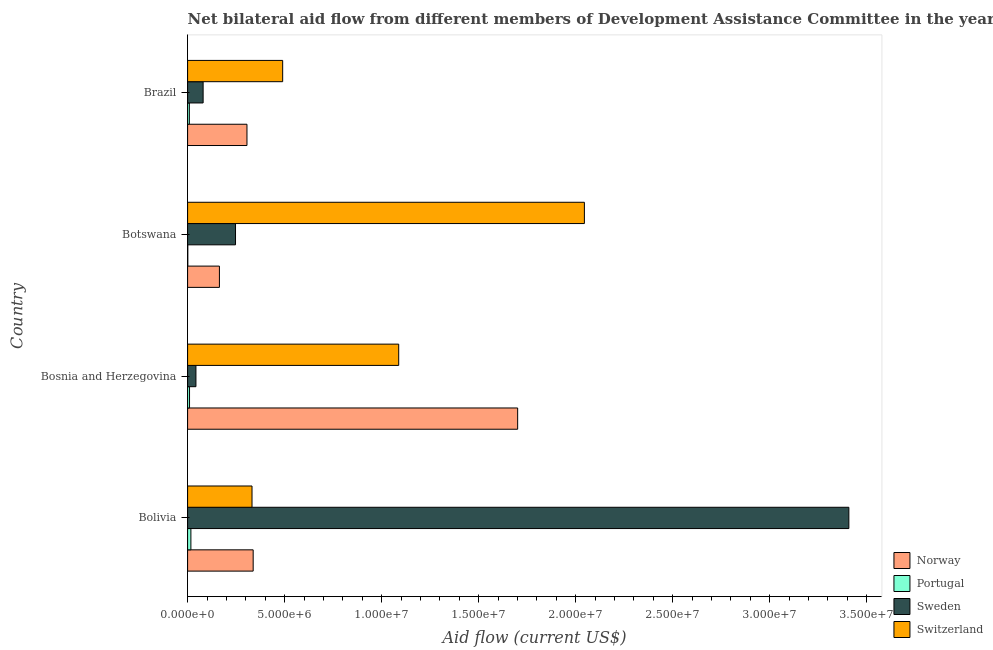How many different coloured bars are there?
Provide a short and direct response. 4. How many groups of bars are there?
Give a very brief answer. 4. Are the number of bars per tick equal to the number of legend labels?
Your answer should be compact. Yes. Are the number of bars on each tick of the Y-axis equal?
Make the answer very short. Yes. How many bars are there on the 1st tick from the bottom?
Provide a succinct answer. 4. What is the label of the 2nd group of bars from the top?
Offer a very short reply. Botswana. In how many cases, is the number of bars for a given country not equal to the number of legend labels?
Your answer should be very brief. 0. What is the amount of aid given by sweden in Bolivia?
Offer a terse response. 3.41e+07. Across all countries, what is the maximum amount of aid given by switzerland?
Provide a succinct answer. 2.04e+07. Across all countries, what is the minimum amount of aid given by portugal?
Ensure brevity in your answer.  10000. In which country was the amount of aid given by norway minimum?
Your answer should be very brief. Botswana. What is the total amount of aid given by switzerland in the graph?
Ensure brevity in your answer.  3.96e+07. What is the difference between the amount of aid given by switzerland in Botswana and that in Brazil?
Give a very brief answer. 1.56e+07. What is the difference between the amount of aid given by switzerland in Brazil and the amount of aid given by portugal in Bolivia?
Provide a short and direct response. 4.73e+06. What is the average amount of aid given by sweden per country?
Offer a terse response. 9.44e+06. What is the difference between the amount of aid given by switzerland and amount of aid given by sweden in Bolivia?
Provide a succinct answer. -3.08e+07. What is the ratio of the amount of aid given by switzerland in Bolivia to that in Botswana?
Keep it short and to the point. 0.16. What is the difference between the highest and the second highest amount of aid given by sweden?
Offer a very short reply. 3.16e+07. What is the difference between the highest and the lowest amount of aid given by sweden?
Make the answer very short. 3.36e+07. In how many countries, is the amount of aid given by switzerland greater than the average amount of aid given by switzerland taken over all countries?
Give a very brief answer. 2. Is the sum of the amount of aid given by portugal in Bolivia and Bosnia and Herzegovina greater than the maximum amount of aid given by norway across all countries?
Your response must be concise. No. What does the 1st bar from the bottom in Bosnia and Herzegovina represents?
Your response must be concise. Norway. Are all the bars in the graph horizontal?
Your response must be concise. Yes. Are the values on the major ticks of X-axis written in scientific E-notation?
Your response must be concise. Yes. Does the graph contain grids?
Give a very brief answer. No. Where does the legend appear in the graph?
Give a very brief answer. Bottom right. How many legend labels are there?
Provide a succinct answer. 4. How are the legend labels stacked?
Offer a very short reply. Vertical. What is the title of the graph?
Offer a terse response. Net bilateral aid flow from different members of Development Assistance Committee in the year 2004. What is the label or title of the X-axis?
Give a very brief answer. Aid flow (current US$). What is the Aid flow (current US$) in Norway in Bolivia?
Your answer should be very brief. 3.38e+06. What is the Aid flow (current US$) in Sweden in Bolivia?
Provide a short and direct response. 3.41e+07. What is the Aid flow (current US$) in Switzerland in Bolivia?
Offer a very short reply. 3.32e+06. What is the Aid flow (current US$) in Norway in Bosnia and Herzegovina?
Provide a succinct answer. 1.70e+07. What is the Aid flow (current US$) in Portugal in Bosnia and Herzegovina?
Provide a short and direct response. 1.00e+05. What is the Aid flow (current US$) in Switzerland in Bosnia and Herzegovina?
Your response must be concise. 1.09e+07. What is the Aid flow (current US$) of Norway in Botswana?
Give a very brief answer. 1.64e+06. What is the Aid flow (current US$) of Sweden in Botswana?
Your answer should be very brief. 2.47e+06. What is the Aid flow (current US$) in Switzerland in Botswana?
Give a very brief answer. 2.04e+07. What is the Aid flow (current US$) of Norway in Brazil?
Provide a short and direct response. 3.06e+06. What is the Aid flow (current US$) of Sweden in Brazil?
Provide a succinct answer. 8.00e+05. What is the Aid flow (current US$) of Switzerland in Brazil?
Give a very brief answer. 4.90e+06. Across all countries, what is the maximum Aid flow (current US$) in Norway?
Give a very brief answer. 1.70e+07. Across all countries, what is the maximum Aid flow (current US$) in Portugal?
Make the answer very short. 1.70e+05. Across all countries, what is the maximum Aid flow (current US$) in Sweden?
Your answer should be very brief. 3.41e+07. Across all countries, what is the maximum Aid flow (current US$) in Switzerland?
Provide a succinct answer. 2.04e+07. Across all countries, what is the minimum Aid flow (current US$) in Norway?
Provide a short and direct response. 1.64e+06. Across all countries, what is the minimum Aid flow (current US$) in Portugal?
Your answer should be very brief. 10000. Across all countries, what is the minimum Aid flow (current US$) in Switzerland?
Ensure brevity in your answer.  3.32e+06. What is the total Aid flow (current US$) of Norway in the graph?
Your answer should be very brief. 2.51e+07. What is the total Aid flow (current US$) of Portugal in the graph?
Your answer should be very brief. 3.70e+05. What is the total Aid flow (current US$) of Sweden in the graph?
Offer a very short reply. 3.78e+07. What is the total Aid flow (current US$) in Switzerland in the graph?
Your response must be concise. 3.96e+07. What is the difference between the Aid flow (current US$) of Norway in Bolivia and that in Bosnia and Herzegovina?
Your response must be concise. -1.36e+07. What is the difference between the Aid flow (current US$) of Sweden in Bolivia and that in Bosnia and Herzegovina?
Offer a very short reply. 3.36e+07. What is the difference between the Aid flow (current US$) of Switzerland in Bolivia and that in Bosnia and Herzegovina?
Give a very brief answer. -7.56e+06. What is the difference between the Aid flow (current US$) in Norway in Bolivia and that in Botswana?
Give a very brief answer. 1.74e+06. What is the difference between the Aid flow (current US$) of Sweden in Bolivia and that in Botswana?
Your answer should be very brief. 3.16e+07. What is the difference between the Aid flow (current US$) of Switzerland in Bolivia and that in Botswana?
Provide a short and direct response. -1.71e+07. What is the difference between the Aid flow (current US$) in Norway in Bolivia and that in Brazil?
Provide a short and direct response. 3.20e+05. What is the difference between the Aid flow (current US$) in Portugal in Bolivia and that in Brazil?
Ensure brevity in your answer.  8.00e+04. What is the difference between the Aid flow (current US$) of Sweden in Bolivia and that in Brazil?
Give a very brief answer. 3.33e+07. What is the difference between the Aid flow (current US$) of Switzerland in Bolivia and that in Brazil?
Keep it short and to the point. -1.58e+06. What is the difference between the Aid flow (current US$) of Norway in Bosnia and Herzegovina and that in Botswana?
Offer a terse response. 1.54e+07. What is the difference between the Aid flow (current US$) of Portugal in Bosnia and Herzegovina and that in Botswana?
Provide a succinct answer. 9.00e+04. What is the difference between the Aid flow (current US$) in Sweden in Bosnia and Herzegovina and that in Botswana?
Make the answer very short. -2.04e+06. What is the difference between the Aid flow (current US$) of Switzerland in Bosnia and Herzegovina and that in Botswana?
Your answer should be very brief. -9.57e+06. What is the difference between the Aid flow (current US$) of Norway in Bosnia and Herzegovina and that in Brazil?
Provide a succinct answer. 1.40e+07. What is the difference between the Aid flow (current US$) of Portugal in Bosnia and Herzegovina and that in Brazil?
Keep it short and to the point. 10000. What is the difference between the Aid flow (current US$) of Sweden in Bosnia and Herzegovina and that in Brazil?
Make the answer very short. -3.70e+05. What is the difference between the Aid flow (current US$) in Switzerland in Bosnia and Herzegovina and that in Brazil?
Provide a short and direct response. 5.98e+06. What is the difference between the Aid flow (current US$) in Norway in Botswana and that in Brazil?
Offer a terse response. -1.42e+06. What is the difference between the Aid flow (current US$) of Sweden in Botswana and that in Brazil?
Your answer should be compact. 1.67e+06. What is the difference between the Aid flow (current US$) in Switzerland in Botswana and that in Brazil?
Provide a succinct answer. 1.56e+07. What is the difference between the Aid flow (current US$) of Norway in Bolivia and the Aid flow (current US$) of Portugal in Bosnia and Herzegovina?
Ensure brevity in your answer.  3.28e+06. What is the difference between the Aid flow (current US$) of Norway in Bolivia and the Aid flow (current US$) of Sweden in Bosnia and Herzegovina?
Make the answer very short. 2.95e+06. What is the difference between the Aid flow (current US$) of Norway in Bolivia and the Aid flow (current US$) of Switzerland in Bosnia and Herzegovina?
Provide a succinct answer. -7.50e+06. What is the difference between the Aid flow (current US$) in Portugal in Bolivia and the Aid flow (current US$) in Switzerland in Bosnia and Herzegovina?
Your answer should be very brief. -1.07e+07. What is the difference between the Aid flow (current US$) in Sweden in Bolivia and the Aid flow (current US$) in Switzerland in Bosnia and Herzegovina?
Keep it short and to the point. 2.32e+07. What is the difference between the Aid flow (current US$) in Norway in Bolivia and the Aid flow (current US$) in Portugal in Botswana?
Make the answer very short. 3.37e+06. What is the difference between the Aid flow (current US$) in Norway in Bolivia and the Aid flow (current US$) in Sweden in Botswana?
Make the answer very short. 9.10e+05. What is the difference between the Aid flow (current US$) of Norway in Bolivia and the Aid flow (current US$) of Switzerland in Botswana?
Make the answer very short. -1.71e+07. What is the difference between the Aid flow (current US$) in Portugal in Bolivia and the Aid flow (current US$) in Sweden in Botswana?
Give a very brief answer. -2.30e+06. What is the difference between the Aid flow (current US$) of Portugal in Bolivia and the Aid flow (current US$) of Switzerland in Botswana?
Make the answer very short. -2.03e+07. What is the difference between the Aid flow (current US$) in Sweden in Bolivia and the Aid flow (current US$) in Switzerland in Botswana?
Ensure brevity in your answer.  1.36e+07. What is the difference between the Aid flow (current US$) of Norway in Bolivia and the Aid flow (current US$) of Portugal in Brazil?
Make the answer very short. 3.29e+06. What is the difference between the Aid flow (current US$) in Norway in Bolivia and the Aid flow (current US$) in Sweden in Brazil?
Provide a short and direct response. 2.58e+06. What is the difference between the Aid flow (current US$) in Norway in Bolivia and the Aid flow (current US$) in Switzerland in Brazil?
Your answer should be very brief. -1.52e+06. What is the difference between the Aid flow (current US$) of Portugal in Bolivia and the Aid flow (current US$) of Sweden in Brazil?
Your answer should be compact. -6.30e+05. What is the difference between the Aid flow (current US$) of Portugal in Bolivia and the Aid flow (current US$) of Switzerland in Brazil?
Provide a succinct answer. -4.73e+06. What is the difference between the Aid flow (current US$) in Sweden in Bolivia and the Aid flow (current US$) in Switzerland in Brazil?
Provide a succinct answer. 2.92e+07. What is the difference between the Aid flow (current US$) of Norway in Bosnia and Herzegovina and the Aid flow (current US$) of Portugal in Botswana?
Your response must be concise. 1.70e+07. What is the difference between the Aid flow (current US$) of Norway in Bosnia and Herzegovina and the Aid flow (current US$) of Sweden in Botswana?
Offer a very short reply. 1.45e+07. What is the difference between the Aid flow (current US$) of Norway in Bosnia and Herzegovina and the Aid flow (current US$) of Switzerland in Botswana?
Your answer should be very brief. -3.44e+06. What is the difference between the Aid flow (current US$) in Portugal in Bosnia and Herzegovina and the Aid flow (current US$) in Sweden in Botswana?
Give a very brief answer. -2.37e+06. What is the difference between the Aid flow (current US$) in Portugal in Bosnia and Herzegovina and the Aid flow (current US$) in Switzerland in Botswana?
Ensure brevity in your answer.  -2.04e+07. What is the difference between the Aid flow (current US$) of Sweden in Bosnia and Herzegovina and the Aid flow (current US$) of Switzerland in Botswana?
Offer a terse response. -2.00e+07. What is the difference between the Aid flow (current US$) in Norway in Bosnia and Herzegovina and the Aid flow (current US$) in Portugal in Brazil?
Provide a short and direct response. 1.69e+07. What is the difference between the Aid flow (current US$) of Norway in Bosnia and Herzegovina and the Aid flow (current US$) of Sweden in Brazil?
Ensure brevity in your answer.  1.62e+07. What is the difference between the Aid flow (current US$) in Norway in Bosnia and Herzegovina and the Aid flow (current US$) in Switzerland in Brazil?
Your response must be concise. 1.21e+07. What is the difference between the Aid flow (current US$) in Portugal in Bosnia and Herzegovina and the Aid flow (current US$) in Sweden in Brazil?
Make the answer very short. -7.00e+05. What is the difference between the Aid flow (current US$) of Portugal in Bosnia and Herzegovina and the Aid flow (current US$) of Switzerland in Brazil?
Keep it short and to the point. -4.80e+06. What is the difference between the Aid flow (current US$) in Sweden in Bosnia and Herzegovina and the Aid flow (current US$) in Switzerland in Brazil?
Offer a very short reply. -4.47e+06. What is the difference between the Aid flow (current US$) of Norway in Botswana and the Aid flow (current US$) of Portugal in Brazil?
Keep it short and to the point. 1.55e+06. What is the difference between the Aid flow (current US$) of Norway in Botswana and the Aid flow (current US$) of Sweden in Brazil?
Your answer should be very brief. 8.40e+05. What is the difference between the Aid flow (current US$) of Norway in Botswana and the Aid flow (current US$) of Switzerland in Brazil?
Provide a short and direct response. -3.26e+06. What is the difference between the Aid flow (current US$) in Portugal in Botswana and the Aid flow (current US$) in Sweden in Brazil?
Provide a succinct answer. -7.90e+05. What is the difference between the Aid flow (current US$) of Portugal in Botswana and the Aid flow (current US$) of Switzerland in Brazil?
Provide a short and direct response. -4.89e+06. What is the difference between the Aid flow (current US$) in Sweden in Botswana and the Aid flow (current US$) in Switzerland in Brazil?
Your answer should be very brief. -2.43e+06. What is the average Aid flow (current US$) in Norway per country?
Make the answer very short. 6.27e+06. What is the average Aid flow (current US$) of Portugal per country?
Your answer should be very brief. 9.25e+04. What is the average Aid flow (current US$) of Sweden per country?
Your answer should be very brief. 9.44e+06. What is the average Aid flow (current US$) in Switzerland per country?
Make the answer very short. 9.89e+06. What is the difference between the Aid flow (current US$) of Norway and Aid flow (current US$) of Portugal in Bolivia?
Give a very brief answer. 3.21e+06. What is the difference between the Aid flow (current US$) of Norway and Aid flow (current US$) of Sweden in Bolivia?
Your response must be concise. -3.07e+07. What is the difference between the Aid flow (current US$) in Norway and Aid flow (current US$) in Switzerland in Bolivia?
Provide a short and direct response. 6.00e+04. What is the difference between the Aid flow (current US$) of Portugal and Aid flow (current US$) of Sweden in Bolivia?
Your answer should be very brief. -3.39e+07. What is the difference between the Aid flow (current US$) of Portugal and Aid flow (current US$) of Switzerland in Bolivia?
Ensure brevity in your answer.  -3.15e+06. What is the difference between the Aid flow (current US$) in Sweden and Aid flow (current US$) in Switzerland in Bolivia?
Your answer should be compact. 3.08e+07. What is the difference between the Aid flow (current US$) of Norway and Aid flow (current US$) of Portugal in Bosnia and Herzegovina?
Ensure brevity in your answer.  1.69e+07. What is the difference between the Aid flow (current US$) of Norway and Aid flow (current US$) of Sweden in Bosnia and Herzegovina?
Your response must be concise. 1.66e+07. What is the difference between the Aid flow (current US$) of Norway and Aid flow (current US$) of Switzerland in Bosnia and Herzegovina?
Ensure brevity in your answer.  6.13e+06. What is the difference between the Aid flow (current US$) of Portugal and Aid flow (current US$) of Sweden in Bosnia and Herzegovina?
Keep it short and to the point. -3.30e+05. What is the difference between the Aid flow (current US$) in Portugal and Aid flow (current US$) in Switzerland in Bosnia and Herzegovina?
Offer a terse response. -1.08e+07. What is the difference between the Aid flow (current US$) in Sweden and Aid flow (current US$) in Switzerland in Bosnia and Herzegovina?
Your answer should be compact. -1.04e+07. What is the difference between the Aid flow (current US$) of Norway and Aid flow (current US$) of Portugal in Botswana?
Offer a very short reply. 1.63e+06. What is the difference between the Aid flow (current US$) in Norway and Aid flow (current US$) in Sweden in Botswana?
Make the answer very short. -8.30e+05. What is the difference between the Aid flow (current US$) in Norway and Aid flow (current US$) in Switzerland in Botswana?
Your response must be concise. -1.88e+07. What is the difference between the Aid flow (current US$) in Portugal and Aid flow (current US$) in Sweden in Botswana?
Ensure brevity in your answer.  -2.46e+06. What is the difference between the Aid flow (current US$) of Portugal and Aid flow (current US$) of Switzerland in Botswana?
Provide a short and direct response. -2.04e+07. What is the difference between the Aid flow (current US$) of Sweden and Aid flow (current US$) of Switzerland in Botswana?
Provide a short and direct response. -1.80e+07. What is the difference between the Aid flow (current US$) in Norway and Aid flow (current US$) in Portugal in Brazil?
Ensure brevity in your answer.  2.97e+06. What is the difference between the Aid flow (current US$) in Norway and Aid flow (current US$) in Sweden in Brazil?
Provide a short and direct response. 2.26e+06. What is the difference between the Aid flow (current US$) of Norway and Aid flow (current US$) of Switzerland in Brazil?
Offer a very short reply. -1.84e+06. What is the difference between the Aid flow (current US$) of Portugal and Aid flow (current US$) of Sweden in Brazil?
Your answer should be very brief. -7.10e+05. What is the difference between the Aid flow (current US$) in Portugal and Aid flow (current US$) in Switzerland in Brazil?
Your response must be concise. -4.81e+06. What is the difference between the Aid flow (current US$) in Sweden and Aid flow (current US$) in Switzerland in Brazil?
Provide a short and direct response. -4.10e+06. What is the ratio of the Aid flow (current US$) of Norway in Bolivia to that in Bosnia and Herzegovina?
Give a very brief answer. 0.2. What is the ratio of the Aid flow (current US$) of Portugal in Bolivia to that in Bosnia and Herzegovina?
Make the answer very short. 1.7. What is the ratio of the Aid flow (current US$) of Sweden in Bolivia to that in Bosnia and Herzegovina?
Your response must be concise. 79.26. What is the ratio of the Aid flow (current US$) of Switzerland in Bolivia to that in Bosnia and Herzegovina?
Offer a very short reply. 0.31. What is the ratio of the Aid flow (current US$) in Norway in Bolivia to that in Botswana?
Offer a very short reply. 2.06. What is the ratio of the Aid flow (current US$) of Portugal in Bolivia to that in Botswana?
Your answer should be very brief. 17. What is the ratio of the Aid flow (current US$) in Sweden in Bolivia to that in Botswana?
Provide a short and direct response. 13.8. What is the ratio of the Aid flow (current US$) in Switzerland in Bolivia to that in Botswana?
Provide a short and direct response. 0.16. What is the ratio of the Aid flow (current US$) in Norway in Bolivia to that in Brazil?
Offer a terse response. 1.1. What is the ratio of the Aid flow (current US$) of Portugal in Bolivia to that in Brazil?
Your response must be concise. 1.89. What is the ratio of the Aid flow (current US$) in Sweden in Bolivia to that in Brazil?
Ensure brevity in your answer.  42.6. What is the ratio of the Aid flow (current US$) in Switzerland in Bolivia to that in Brazil?
Provide a short and direct response. 0.68. What is the ratio of the Aid flow (current US$) in Norway in Bosnia and Herzegovina to that in Botswana?
Keep it short and to the point. 10.37. What is the ratio of the Aid flow (current US$) of Sweden in Bosnia and Herzegovina to that in Botswana?
Give a very brief answer. 0.17. What is the ratio of the Aid flow (current US$) in Switzerland in Bosnia and Herzegovina to that in Botswana?
Offer a terse response. 0.53. What is the ratio of the Aid flow (current US$) of Norway in Bosnia and Herzegovina to that in Brazil?
Offer a terse response. 5.56. What is the ratio of the Aid flow (current US$) in Sweden in Bosnia and Herzegovina to that in Brazil?
Your answer should be compact. 0.54. What is the ratio of the Aid flow (current US$) of Switzerland in Bosnia and Herzegovina to that in Brazil?
Provide a short and direct response. 2.22. What is the ratio of the Aid flow (current US$) of Norway in Botswana to that in Brazil?
Provide a succinct answer. 0.54. What is the ratio of the Aid flow (current US$) of Portugal in Botswana to that in Brazil?
Keep it short and to the point. 0.11. What is the ratio of the Aid flow (current US$) of Sweden in Botswana to that in Brazil?
Provide a succinct answer. 3.09. What is the ratio of the Aid flow (current US$) of Switzerland in Botswana to that in Brazil?
Your answer should be very brief. 4.17. What is the difference between the highest and the second highest Aid flow (current US$) of Norway?
Your answer should be very brief. 1.36e+07. What is the difference between the highest and the second highest Aid flow (current US$) in Portugal?
Your answer should be very brief. 7.00e+04. What is the difference between the highest and the second highest Aid flow (current US$) in Sweden?
Offer a very short reply. 3.16e+07. What is the difference between the highest and the second highest Aid flow (current US$) of Switzerland?
Make the answer very short. 9.57e+06. What is the difference between the highest and the lowest Aid flow (current US$) in Norway?
Offer a terse response. 1.54e+07. What is the difference between the highest and the lowest Aid flow (current US$) in Portugal?
Ensure brevity in your answer.  1.60e+05. What is the difference between the highest and the lowest Aid flow (current US$) in Sweden?
Give a very brief answer. 3.36e+07. What is the difference between the highest and the lowest Aid flow (current US$) of Switzerland?
Your answer should be very brief. 1.71e+07. 